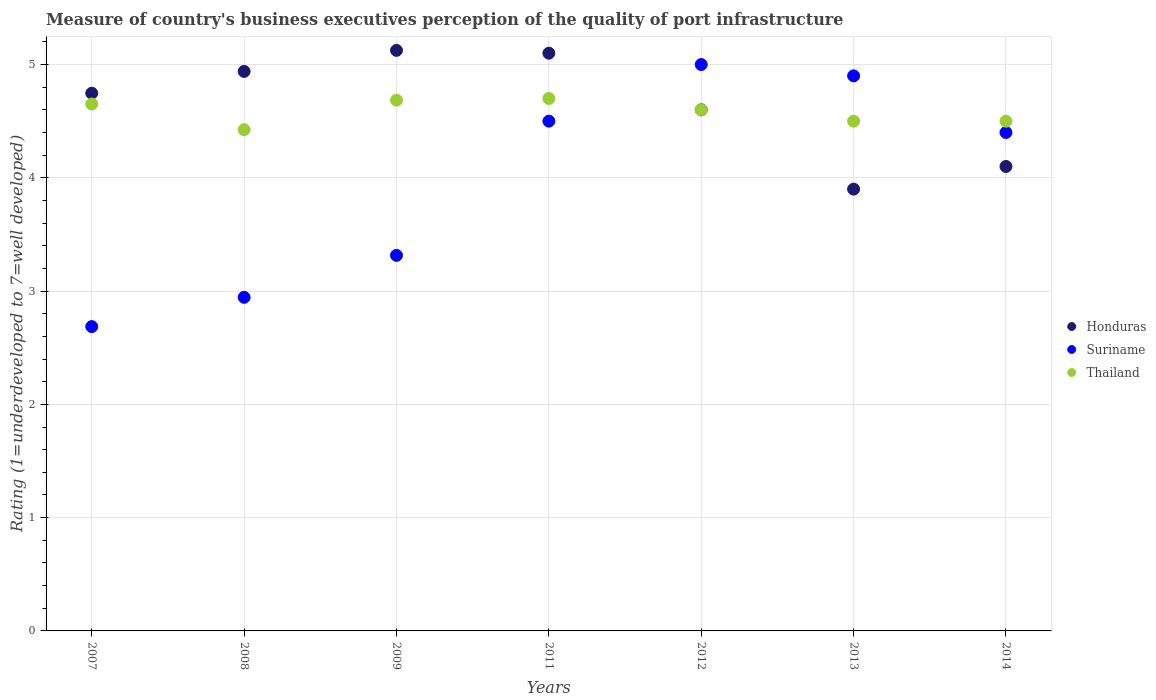Is the number of dotlines equal to the number of legend labels?
Make the answer very short. Yes. Across all years, what is the maximum ratings of the quality of port infrastructure in Suriname?
Provide a succinct answer. 5. Across all years, what is the minimum ratings of the quality of port infrastructure in Thailand?
Provide a succinct answer. 4.42. In which year was the ratings of the quality of port infrastructure in Thailand minimum?
Provide a short and direct response. 2008. What is the total ratings of the quality of port infrastructure in Thailand in the graph?
Provide a short and direct response. 32.06. What is the difference between the ratings of the quality of port infrastructure in Suriname in 2011 and that in 2014?
Make the answer very short. 0.1. What is the difference between the ratings of the quality of port infrastructure in Thailand in 2011 and the ratings of the quality of port infrastructure in Suriname in 2013?
Ensure brevity in your answer.  -0.2. What is the average ratings of the quality of port infrastructure in Honduras per year?
Your answer should be compact. 4.64. In the year 2011, what is the difference between the ratings of the quality of port infrastructure in Thailand and ratings of the quality of port infrastructure in Suriname?
Offer a terse response. 0.2. What is the ratio of the ratings of the quality of port infrastructure in Honduras in 2007 to that in 2014?
Offer a very short reply. 1.16. Is the ratings of the quality of port infrastructure in Honduras in 2007 less than that in 2011?
Offer a terse response. Yes. What is the difference between the highest and the second highest ratings of the quality of port infrastructure in Thailand?
Offer a terse response. 0.01. What is the difference between the highest and the lowest ratings of the quality of port infrastructure in Suriname?
Your answer should be compact. 2.31. In how many years, is the ratings of the quality of port infrastructure in Thailand greater than the average ratings of the quality of port infrastructure in Thailand taken over all years?
Your answer should be compact. 4. Is it the case that in every year, the sum of the ratings of the quality of port infrastructure in Thailand and ratings of the quality of port infrastructure in Suriname  is greater than the ratings of the quality of port infrastructure in Honduras?
Give a very brief answer. Yes. Is the ratings of the quality of port infrastructure in Suriname strictly less than the ratings of the quality of port infrastructure in Thailand over the years?
Provide a succinct answer. No. Are the values on the major ticks of Y-axis written in scientific E-notation?
Your response must be concise. No. Does the graph contain grids?
Provide a succinct answer. Yes. How are the legend labels stacked?
Make the answer very short. Vertical. What is the title of the graph?
Provide a succinct answer. Measure of country's business executives perception of the quality of port infrastructure. Does "American Samoa" appear as one of the legend labels in the graph?
Your answer should be very brief. No. What is the label or title of the Y-axis?
Provide a short and direct response. Rating (1=underdeveloped to 7=well developed). What is the Rating (1=underdeveloped to 7=well developed) in Honduras in 2007?
Ensure brevity in your answer.  4.75. What is the Rating (1=underdeveloped to 7=well developed) in Suriname in 2007?
Make the answer very short. 2.69. What is the Rating (1=underdeveloped to 7=well developed) of Thailand in 2007?
Your answer should be very brief. 4.65. What is the Rating (1=underdeveloped to 7=well developed) in Honduras in 2008?
Your answer should be very brief. 4.94. What is the Rating (1=underdeveloped to 7=well developed) of Suriname in 2008?
Provide a succinct answer. 2.94. What is the Rating (1=underdeveloped to 7=well developed) in Thailand in 2008?
Provide a succinct answer. 4.42. What is the Rating (1=underdeveloped to 7=well developed) in Honduras in 2009?
Your answer should be compact. 5.12. What is the Rating (1=underdeveloped to 7=well developed) of Suriname in 2009?
Your response must be concise. 3.32. What is the Rating (1=underdeveloped to 7=well developed) in Thailand in 2009?
Keep it short and to the point. 4.69. What is the Rating (1=underdeveloped to 7=well developed) in Honduras in 2011?
Offer a very short reply. 5.1. What is the Rating (1=underdeveloped to 7=well developed) in Suriname in 2011?
Your response must be concise. 4.5. What is the Rating (1=underdeveloped to 7=well developed) in Thailand in 2011?
Your answer should be compact. 4.7. What is the Rating (1=underdeveloped to 7=well developed) of Honduras in 2012?
Give a very brief answer. 4.6. What is the Rating (1=underdeveloped to 7=well developed) in Suriname in 2012?
Your answer should be very brief. 5. What is the Rating (1=underdeveloped to 7=well developed) in Thailand in 2012?
Your answer should be very brief. 4.6. What is the Rating (1=underdeveloped to 7=well developed) of Honduras in 2013?
Provide a short and direct response. 3.9. What is the Rating (1=underdeveloped to 7=well developed) of Suriname in 2013?
Give a very brief answer. 4.9. What is the Rating (1=underdeveloped to 7=well developed) in Thailand in 2013?
Provide a short and direct response. 4.5. What is the Rating (1=underdeveloped to 7=well developed) of Suriname in 2014?
Offer a terse response. 4.4. What is the Rating (1=underdeveloped to 7=well developed) of Thailand in 2014?
Give a very brief answer. 4.5. Across all years, what is the maximum Rating (1=underdeveloped to 7=well developed) of Honduras?
Make the answer very short. 5.12. Across all years, what is the maximum Rating (1=underdeveloped to 7=well developed) of Suriname?
Ensure brevity in your answer.  5. Across all years, what is the maximum Rating (1=underdeveloped to 7=well developed) of Thailand?
Provide a short and direct response. 4.7. Across all years, what is the minimum Rating (1=underdeveloped to 7=well developed) in Suriname?
Your response must be concise. 2.69. Across all years, what is the minimum Rating (1=underdeveloped to 7=well developed) in Thailand?
Make the answer very short. 4.42. What is the total Rating (1=underdeveloped to 7=well developed) in Honduras in the graph?
Keep it short and to the point. 32.51. What is the total Rating (1=underdeveloped to 7=well developed) in Suriname in the graph?
Give a very brief answer. 27.75. What is the total Rating (1=underdeveloped to 7=well developed) of Thailand in the graph?
Your answer should be compact. 32.06. What is the difference between the Rating (1=underdeveloped to 7=well developed) in Honduras in 2007 and that in 2008?
Ensure brevity in your answer.  -0.19. What is the difference between the Rating (1=underdeveloped to 7=well developed) of Suriname in 2007 and that in 2008?
Your answer should be compact. -0.26. What is the difference between the Rating (1=underdeveloped to 7=well developed) of Thailand in 2007 and that in 2008?
Ensure brevity in your answer.  0.23. What is the difference between the Rating (1=underdeveloped to 7=well developed) in Honduras in 2007 and that in 2009?
Provide a succinct answer. -0.38. What is the difference between the Rating (1=underdeveloped to 7=well developed) in Suriname in 2007 and that in 2009?
Offer a terse response. -0.63. What is the difference between the Rating (1=underdeveloped to 7=well developed) of Thailand in 2007 and that in 2009?
Offer a terse response. -0.03. What is the difference between the Rating (1=underdeveloped to 7=well developed) of Honduras in 2007 and that in 2011?
Provide a short and direct response. -0.35. What is the difference between the Rating (1=underdeveloped to 7=well developed) in Suriname in 2007 and that in 2011?
Offer a very short reply. -1.81. What is the difference between the Rating (1=underdeveloped to 7=well developed) of Thailand in 2007 and that in 2011?
Your answer should be very brief. -0.05. What is the difference between the Rating (1=underdeveloped to 7=well developed) in Honduras in 2007 and that in 2012?
Give a very brief answer. 0.15. What is the difference between the Rating (1=underdeveloped to 7=well developed) in Suriname in 2007 and that in 2012?
Your response must be concise. -2.31. What is the difference between the Rating (1=underdeveloped to 7=well developed) of Thailand in 2007 and that in 2012?
Ensure brevity in your answer.  0.05. What is the difference between the Rating (1=underdeveloped to 7=well developed) in Honduras in 2007 and that in 2013?
Ensure brevity in your answer.  0.85. What is the difference between the Rating (1=underdeveloped to 7=well developed) in Suriname in 2007 and that in 2013?
Keep it short and to the point. -2.21. What is the difference between the Rating (1=underdeveloped to 7=well developed) in Thailand in 2007 and that in 2013?
Your response must be concise. 0.15. What is the difference between the Rating (1=underdeveloped to 7=well developed) in Honduras in 2007 and that in 2014?
Make the answer very short. 0.65. What is the difference between the Rating (1=underdeveloped to 7=well developed) in Suriname in 2007 and that in 2014?
Offer a very short reply. -1.71. What is the difference between the Rating (1=underdeveloped to 7=well developed) of Thailand in 2007 and that in 2014?
Provide a short and direct response. 0.15. What is the difference between the Rating (1=underdeveloped to 7=well developed) in Honduras in 2008 and that in 2009?
Your answer should be very brief. -0.19. What is the difference between the Rating (1=underdeveloped to 7=well developed) in Suriname in 2008 and that in 2009?
Ensure brevity in your answer.  -0.37. What is the difference between the Rating (1=underdeveloped to 7=well developed) in Thailand in 2008 and that in 2009?
Ensure brevity in your answer.  -0.26. What is the difference between the Rating (1=underdeveloped to 7=well developed) in Honduras in 2008 and that in 2011?
Your answer should be compact. -0.16. What is the difference between the Rating (1=underdeveloped to 7=well developed) of Suriname in 2008 and that in 2011?
Provide a succinct answer. -1.55. What is the difference between the Rating (1=underdeveloped to 7=well developed) of Thailand in 2008 and that in 2011?
Provide a short and direct response. -0.28. What is the difference between the Rating (1=underdeveloped to 7=well developed) in Honduras in 2008 and that in 2012?
Your response must be concise. 0.34. What is the difference between the Rating (1=underdeveloped to 7=well developed) in Suriname in 2008 and that in 2012?
Make the answer very short. -2.06. What is the difference between the Rating (1=underdeveloped to 7=well developed) in Thailand in 2008 and that in 2012?
Ensure brevity in your answer.  -0.18. What is the difference between the Rating (1=underdeveloped to 7=well developed) in Honduras in 2008 and that in 2013?
Ensure brevity in your answer.  1.04. What is the difference between the Rating (1=underdeveloped to 7=well developed) of Suriname in 2008 and that in 2013?
Provide a short and direct response. -1.96. What is the difference between the Rating (1=underdeveloped to 7=well developed) in Thailand in 2008 and that in 2013?
Provide a short and direct response. -0.08. What is the difference between the Rating (1=underdeveloped to 7=well developed) in Honduras in 2008 and that in 2014?
Your answer should be compact. 0.84. What is the difference between the Rating (1=underdeveloped to 7=well developed) in Suriname in 2008 and that in 2014?
Make the answer very short. -1.46. What is the difference between the Rating (1=underdeveloped to 7=well developed) of Thailand in 2008 and that in 2014?
Provide a short and direct response. -0.08. What is the difference between the Rating (1=underdeveloped to 7=well developed) in Honduras in 2009 and that in 2011?
Provide a succinct answer. 0.02. What is the difference between the Rating (1=underdeveloped to 7=well developed) in Suriname in 2009 and that in 2011?
Provide a succinct answer. -1.18. What is the difference between the Rating (1=underdeveloped to 7=well developed) in Thailand in 2009 and that in 2011?
Make the answer very short. -0.01. What is the difference between the Rating (1=underdeveloped to 7=well developed) of Honduras in 2009 and that in 2012?
Your answer should be very brief. 0.52. What is the difference between the Rating (1=underdeveloped to 7=well developed) in Suriname in 2009 and that in 2012?
Offer a very short reply. -1.68. What is the difference between the Rating (1=underdeveloped to 7=well developed) of Thailand in 2009 and that in 2012?
Keep it short and to the point. 0.09. What is the difference between the Rating (1=underdeveloped to 7=well developed) in Honduras in 2009 and that in 2013?
Your response must be concise. 1.22. What is the difference between the Rating (1=underdeveloped to 7=well developed) of Suriname in 2009 and that in 2013?
Provide a succinct answer. -1.58. What is the difference between the Rating (1=underdeveloped to 7=well developed) in Thailand in 2009 and that in 2013?
Provide a short and direct response. 0.19. What is the difference between the Rating (1=underdeveloped to 7=well developed) in Honduras in 2009 and that in 2014?
Give a very brief answer. 1.02. What is the difference between the Rating (1=underdeveloped to 7=well developed) of Suriname in 2009 and that in 2014?
Provide a short and direct response. -1.08. What is the difference between the Rating (1=underdeveloped to 7=well developed) in Thailand in 2009 and that in 2014?
Your answer should be very brief. 0.19. What is the difference between the Rating (1=underdeveloped to 7=well developed) in Honduras in 2011 and that in 2012?
Provide a short and direct response. 0.5. What is the difference between the Rating (1=underdeveloped to 7=well developed) in Suriname in 2011 and that in 2012?
Ensure brevity in your answer.  -0.5. What is the difference between the Rating (1=underdeveloped to 7=well developed) in Thailand in 2011 and that in 2012?
Give a very brief answer. 0.1. What is the difference between the Rating (1=underdeveloped to 7=well developed) of Suriname in 2011 and that in 2013?
Ensure brevity in your answer.  -0.4. What is the difference between the Rating (1=underdeveloped to 7=well developed) of Thailand in 2011 and that in 2013?
Your answer should be very brief. 0.2. What is the difference between the Rating (1=underdeveloped to 7=well developed) in Honduras in 2012 and that in 2013?
Keep it short and to the point. 0.7. What is the difference between the Rating (1=underdeveloped to 7=well developed) of Thailand in 2012 and that in 2013?
Offer a very short reply. 0.1. What is the difference between the Rating (1=underdeveloped to 7=well developed) of Honduras in 2012 and that in 2014?
Give a very brief answer. 0.5. What is the difference between the Rating (1=underdeveloped to 7=well developed) in Suriname in 2012 and that in 2014?
Make the answer very short. 0.6. What is the difference between the Rating (1=underdeveloped to 7=well developed) in Honduras in 2013 and that in 2014?
Your response must be concise. -0.2. What is the difference between the Rating (1=underdeveloped to 7=well developed) in Honduras in 2007 and the Rating (1=underdeveloped to 7=well developed) in Suriname in 2008?
Your response must be concise. 1.8. What is the difference between the Rating (1=underdeveloped to 7=well developed) of Honduras in 2007 and the Rating (1=underdeveloped to 7=well developed) of Thailand in 2008?
Ensure brevity in your answer.  0.32. What is the difference between the Rating (1=underdeveloped to 7=well developed) in Suriname in 2007 and the Rating (1=underdeveloped to 7=well developed) in Thailand in 2008?
Ensure brevity in your answer.  -1.74. What is the difference between the Rating (1=underdeveloped to 7=well developed) of Honduras in 2007 and the Rating (1=underdeveloped to 7=well developed) of Suriname in 2009?
Provide a succinct answer. 1.43. What is the difference between the Rating (1=underdeveloped to 7=well developed) of Honduras in 2007 and the Rating (1=underdeveloped to 7=well developed) of Thailand in 2009?
Your response must be concise. 0.06. What is the difference between the Rating (1=underdeveloped to 7=well developed) in Suriname in 2007 and the Rating (1=underdeveloped to 7=well developed) in Thailand in 2009?
Your answer should be very brief. -2. What is the difference between the Rating (1=underdeveloped to 7=well developed) in Honduras in 2007 and the Rating (1=underdeveloped to 7=well developed) in Suriname in 2011?
Give a very brief answer. 0.25. What is the difference between the Rating (1=underdeveloped to 7=well developed) in Honduras in 2007 and the Rating (1=underdeveloped to 7=well developed) in Thailand in 2011?
Ensure brevity in your answer.  0.05. What is the difference between the Rating (1=underdeveloped to 7=well developed) of Suriname in 2007 and the Rating (1=underdeveloped to 7=well developed) of Thailand in 2011?
Provide a succinct answer. -2.01. What is the difference between the Rating (1=underdeveloped to 7=well developed) in Honduras in 2007 and the Rating (1=underdeveloped to 7=well developed) in Suriname in 2012?
Ensure brevity in your answer.  -0.25. What is the difference between the Rating (1=underdeveloped to 7=well developed) of Honduras in 2007 and the Rating (1=underdeveloped to 7=well developed) of Thailand in 2012?
Provide a short and direct response. 0.15. What is the difference between the Rating (1=underdeveloped to 7=well developed) of Suriname in 2007 and the Rating (1=underdeveloped to 7=well developed) of Thailand in 2012?
Your answer should be very brief. -1.91. What is the difference between the Rating (1=underdeveloped to 7=well developed) in Honduras in 2007 and the Rating (1=underdeveloped to 7=well developed) in Suriname in 2013?
Your response must be concise. -0.15. What is the difference between the Rating (1=underdeveloped to 7=well developed) of Honduras in 2007 and the Rating (1=underdeveloped to 7=well developed) of Thailand in 2013?
Give a very brief answer. 0.25. What is the difference between the Rating (1=underdeveloped to 7=well developed) of Suriname in 2007 and the Rating (1=underdeveloped to 7=well developed) of Thailand in 2013?
Your answer should be very brief. -1.81. What is the difference between the Rating (1=underdeveloped to 7=well developed) in Honduras in 2007 and the Rating (1=underdeveloped to 7=well developed) in Suriname in 2014?
Your answer should be compact. 0.35. What is the difference between the Rating (1=underdeveloped to 7=well developed) in Honduras in 2007 and the Rating (1=underdeveloped to 7=well developed) in Thailand in 2014?
Make the answer very short. 0.25. What is the difference between the Rating (1=underdeveloped to 7=well developed) of Suriname in 2007 and the Rating (1=underdeveloped to 7=well developed) of Thailand in 2014?
Provide a short and direct response. -1.81. What is the difference between the Rating (1=underdeveloped to 7=well developed) in Honduras in 2008 and the Rating (1=underdeveloped to 7=well developed) in Suriname in 2009?
Your answer should be very brief. 1.62. What is the difference between the Rating (1=underdeveloped to 7=well developed) of Honduras in 2008 and the Rating (1=underdeveloped to 7=well developed) of Thailand in 2009?
Provide a short and direct response. 0.25. What is the difference between the Rating (1=underdeveloped to 7=well developed) in Suriname in 2008 and the Rating (1=underdeveloped to 7=well developed) in Thailand in 2009?
Give a very brief answer. -1.74. What is the difference between the Rating (1=underdeveloped to 7=well developed) in Honduras in 2008 and the Rating (1=underdeveloped to 7=well developed) in Suriname in 2011?
Give a very brief answer. 0.44. What is the difference between the Rating (1=underdeveloped to 7=well developed) of Honduras in 2008 and the Rating (1=underdeveloped to 7=well developed) of Thailand in 2011?
Your response must be concise. 0.24. What is the difference between the Rating (1=underdeveloped to 7=well developed) of Suriname in 2008 and the Rating (1=underdeveloped to 7=well developed) of Thailand in 2011?
Provide a short and direct response. -1.75. What is the difference between the Rating (1=underdeveloped to 7=well developed) of Honduras in 2008 and the Rating (1=underdeveloped to 7=well developed) of Suriname in 2012?
Offer a very short reply. -0.06. What is the difference between the Rating (1=underdeveloped to 7=well developed) of Honduras in 2008 and the Rating (1=underdeveloped to 7=well developed) of Thailand in 2012?
Offer a terse response. 0.34. What is the difference between the Rating (1=underdeveloped to 7=well developed) in Suriname in 2008 and the Rating (1=underdeveloped to 7=well developed) in Thailand in 2012?
Ensure brevity in your answer.  -1.66. What is the difference between the Rating (1=underdeveloped to 7=well developed) in Honduras in 2008 and the Rating (1=underdeveloped to 7=well developed) in Suriname in 2013?
Keep it short and to the point. 0.04. What is the difference between the Rating (1=underdeveloped to 7=well developed) of Honduras in 2008 and the Rating (1=underdeveloped to 7=well developed) of Thailand in 2013?
Offer a terse response. 0.44. What is the difference between the Rating (1=underdeveloped to 7=well developed) in Suriname in 2008 and the Rating (1=underdeveloped to 7=well developed) in Thailand in 2013?
Make the answer very short. -1.55. What is the difference between the Rating (1=underdeveloped to 7=well developed) in Honduras in 2008 and the Rating (1=underdeveloped to 7=well developed) in Suriname in 2014?
Make the answer very short. 0.54. What is the difference between the Rating (1=underdeveloped to 7=well developed) of Honduras in 2008 and the Rating (1=underdeveloped to 7=well developed) of Thailand in 2014?
Keep it short and to the point. 0.44. What is the difference between the Rating (1=underdeveloped to 7=well developed) in Suriname in 2008 and the Rating (1=underdeveloped to 7=well developed) in Thailand in 2014?
Your answer should be compact. -1.55. What is the difference between the Rating (1=underdeveloped to 7=well developed) in Honduras in 2009 and the Rating (1=underdeveloped to 7=well developed) in Suriname in 2011?
Keep it short and to the point. 0.62. What is the difference between the Rating (1=underdeveloped to 7=well developed) of Honduras in 2009 and the Rating (1=underdeveloped to 7=well developed) of Thailand in 2011?
Your response must be concise. 0.42. What is the difference between the Rating (1=underdeveloped to 7=well developed) in Suriname in 2009 and the Rating (1=underdeveloped to 7=well developed) in Thailand in 2011?
Your answer should be very brief. -1.38. What is the difference between the Rating (1=underdeveloped to 7=well developed) in Honduras in 2009 and the Rating (1=underdeveloped to 7=well developed) in Suriname in 2012?
Give a very brief answer. 0.12. What is the difference between the Rating (1=underdeveloped to 7=well developed) of Honduras in 2009 and the Rating (1=underdeveloped to 7=well developed) of Thailand in 2012?
Make the answer very short. 0.52. What is the difference between the Rating (1=underdeveloped to 7=well developed) in Suriname in 2009 and the Rating (1=underdeveloped to 7=well developed) in Thailand in 2012?
Your answer should be compact. -1.28. What is the difference between the Rating (1=underdeveloped to 7=well developed) in Honduras in 2009 and the Rating (1=underdeveloped to 7=well developed) in Suriname in 2013?
Your answer should be compact. 0.22. What is the difference between the Rating (1=underdeveloped to 7=well developed) of Honduras in 2009 and the Rating (1=underdeveloped to 7=well developed) of Thailand in 2013?
Keep it short and to the point. 0.62. What is the difference between the Rating (1=underdeveloped to 7=well developed) in Suriname in 2009 and the Rating (1=underdeveloped to 7=well developed) in Thailand in 2013?
Your answer should be compact. -1.18. What is the difference between the Rating (1=underdeveloped to 7=well developed) in Honduras in 2009 and the Rating (1=underdeveloped to 7=well developed) in Suriname in 2014?
Provide a short and direct response. 0.72. What is the difference between the Rating (1=underdeveloped to 7=well developed) in Honduras in 2009 and the Rating (1=underdeveloped to 7=well developed) in Thailand in 2014?
Provide a short and direct response. 0.62. What is the difference between the Rating (1=underdeveloped to 7=well developed) in Suriname in 2009 and the Rating (1=underdeveloped to 7=well developed) in Thailand in 2014?
Your answer should be very brief. -1.18. What is the difference between the Rating (1=underdeveloped to 7=well developed) in Honduras in 2011 and the Rating (1=underdeveloped to 7=well developed) in Thailand in 2012?
Give a very brief answer. 0.5. What is the difference between the Rating (1=underdeveloped to 7=well developed) of Suriname in 2011 and the Rating (1=underdeveloped to 7=well developed) of Thailand in 2012?
Your answer should be compact. -0.1. What is the difference between the Rating (1=underdeveloped to 7=well developed) in Honduras in 2011 and the Rating (1=underdeveloped to 7=well developed) in Suriname in 2013?
Your response must be concise. 0.2. What is the difference between the Rating (1=underdeveloped to 7=well developed) of Honduras in 2011 and the Rating (1=underdeveloped to 7=well developed) of Thailand in 2013?
Your answer should be compact. 0.6. What is the difference between the Rating (1=underdeveloped to 7=well developed) of Honduras in 2011 and the Rating (1=underdeveloped to 7=well developed) of Suriname in 2014?
Make the answer very short. 0.7. What is the difference between the Rating (1=underdeveloped to 7=well developed) of Honduras in 2011 and the Rating (1=underdeveloped to 7=well developed) of Thailand in 2014?
Give a very brief answer. 0.6. What is the difference between the Rating (1=underdeveloped to 7=well developed) in Honduras in 2012 and the Rating (1=underdeveloped to 7=well developed) in Suriname in 2013?
Offer a very short reply. -0.3. What is the difference between the Rating (1=underdeveloped to 7=well developed) in Honduras in 2012 and the Rating (1=underdeveloped to 7=well developed) in Suriname in 2014?
Your answer should be very brief. 0.2. What is the difference between the Rating (1=underdeveloped to 7=well developed) of Suriname in 2012 and the Rating (1=underdeveloped to 7=well developed) of Thailand in 2014?
Keep it short and to the point. 0.5. What is the difference between the Rating (1=underdeveloped to 7=well developed) in Honduras in 2013 and the Rating (1=underdeveloped to 7=well developed) in Thailand in 2014?
Provide a succinct answer. -0.6. What is the average Rating (1=underdeveloped to 7=well developed) of Honduras per year?
Ensure brevity in your answer.  4.64. What is the average Rating (1=underdeveloped to 7=well developed) of Suriname per year?
Make the answer very short. 3.96. What is the average Rating (1=underdeveloped to 7=well developed) in Thailand per year?
Your response must be concise. 4.58. In the year 2007, what is the difference between the Rating (1=underdeveloped to 7=well developed) of Honduras and Rating (1=underdeveloped to 7=well developed) of Suriname?
Ensure brevity in your answer.  2.06. In the year 2007, what is the difference between the Rating (1=underdeveloped to 7=well developed) of Honduras and Rating (1=underdeveloped to 7=well developed) of Thailand?
Your response must be concise. 0.1. In the year 2007, what is the difference between the Rating (1=underdeveloped to 7=well developed) of Suriname and Rating (1=underdeveloped to 7=well developed) of Thailand?
Offer a terse response. -1.97. In the year 2008, what is the difference between the Rating (1=underdeveloped to 7=well developed) in Honduras and Rating (1=underdeveloped to 7=well developed) in Suriname?
Your response must be concise. 1.99. In the year 2008, what is the difference between the Rating (1=underdeveloped to 7=well developed) of Honduras and Rating (1=underdeveloped to 7=well developed) of Thailand?
Offer a very short reply. 0.51. In the year 2008, what is the difference between the Rating (1=underdeveloped to 7=well developed) in Suriname and Rating (1=underdeveloped to 7=well developed) in Thailand?
Your answer should be compact. -1.48. In the year 2009, what is the difference between the Rating (1=underdeveloped to 7=well developed) in Honduras and Rating (1=underdeveloped to 7=well developed) in Suriname?
Your answer should be compact. 1.81. In the year 2009, what is the difference between the Rating (1=underdeveloped to 7=well developed) in Honduras and Rating (1=underdeveloped to 7=well developed) in Thailand?
Offer a very short reply. 0.44. In the year 2009, what is the difference between the Rating (1=underdeveloped to 7=well developed) in Suriname and Rating (1=underdeveloped to 7=well developed) in Thailand?
Make the answer very short. -1.37. In the year 2011, what is the difference between the Rating (1=underdeveloped to 7=well developed) of Honduras and Rating (1=underdeveloped to 7=well developed) of Thailand?
Provide a succinct answer. 0.4. In the year 2012, what is the difference between the Rating (1=underdeveloped to 7=well developed) of Honduras and Rating (1=underdeveloped to 7=well developed) of Thailand?
Keep it short and to the point. 0. In the year 2012, what is the difference between the Rating (1=underdeveloped to 7=well developed) in Suriname and Rating (1=underdeveloped to 7=well developed) in Thailand?
Ensure brevity in your answer.  0.4. In the year 2014, what is the difference between the Rating (1=underdeveloped to 7=well developed) in Honduras and Rating (1=underdeveloped to 7=well developed) in Suriname?
Provide a succinct answer. -0.3. In the year 2014, what is the difference between the Rating (1=underdeveloped to 7=well developed) in Honduras and Rating (1=underdeveloped to 7=well developed) in Thailand?
Your answer should be compact. -0.4. In the year 2014, what is the difference between the Rating (1=underdeveloped to 7=well developed) of Suriname and Rating (1=underdeveloped to 7=well developed) of Thailand?
Offer a terse response. -0.1. What is the ratio of the Rating (1=underdeveloped to 7=well developed) of Suriname in 2007 to that in 2008?
Provide a short and direct response. 0.91. What is the ratio of the Rating (1=underdeveloped to 7=well developed) of Thailand in 2007 to that in 2008?
Provide a short and direct response. 1.05. What is the ratio of the Rating (1=underdeveloped to 7=well developed) of Honduras in 2007 to that in 2009?
Offer a terse response. 0.93. What is the ratio of the Rating (1=underdeveloped to 7=well developed) of Suriname in 2007 to that in 2009?
Offer a very short reply. 0.81. What is the ratio of the Rating (1=underdeveloped to 7=well developed) in Thailand in 2007 to that in 2009?
Give a very brief answer. 0.99. What is the ratio of the Rating (1=underdeveloped to 7=well developed) in Honduras in 2007 to that in 2011?
Provide a succinct answer. 0.93. What is the ratio of the Rating (1=underdeveloped to 7=well developed) of Suriname in 2007 to that in 2011?
Ensure brevity in your answer.  0.6. What is the ratio of the Rating (1=underdeveloped to 7=well developed) in Honduras in 2007 to that in 2012?
Ensure brevity in your answer.  1.03. What is the ratio of the Rating (1=underdeveloped to 7=well developed) of Suriname in 2007 to that in 2012?
Make the answer very short. 0.54. What is the ratio of the Rating (1=underdeveloped to 7=well developed) in Thailand in 2007 to that in 2012?
Your answer should be very brief. 1.01. What is the ratio of the Rating (1=underdeveloped to 7=well developed) of Honduras in 2007 to that in 2013?
Make the answer very short. 1.22. What is the ratio of the Rating (1=underdeveloped to 7=well developed) of Suriname in 2007 to that in 2013?
Provide a succinct answer. 0.55. What is the ratio of the Rating (1=underdeveloped to 7=well developed) in Thailand in 2007 to that in 2013?
Provide a short and direct response. 1.03. What is the ratio of the Rating (1=underdeveloped to 7=well developed) of Honduras in 2007 to that in 2014?
Ensure brevity in your answer.  1.16. What is the ratio of the Rating (1=underdeveloped to 7=well developed) in Suriname in 2007 to that in 2014?
Provide a succinct answer. 0.61. What is the ratio of the Rating (1=underdeveloped to 7=well developed) in Thailand in 2007 to that in 2014?
Your answer should be compact. 1.03. What is the ratio of the Rating (1=underdeveloped to 7=well developed) in Honduras in 2008 to that in 2009?
Your answer should be compact. 0.96. What is the ratio of the Rating (1=underdeveloped to 7=well developed) of Suriname in 2008 to that in 2009?
Ensure brevity in your answer.  0.89. What is the ratio of the Rating (1=underdeveloped to 7=well developed) in Thailand in 2008 to that in 2009?
Make the answer very short. 0.94. What is the ratio of the Rating (1=underdeveloped to 7=well developed) of Honduras in 2008 to that in 2011?
Your answer should be compact. 0.97. What is the ratio of the Rating (1=underdeveloped to 7=well developed) of Suriname in 2008 to that in 2011?
Offer a terse response. 0.65. What is the ratio of the Rating (1=underdeveloped to 7=well developed) of Thailand in 2008 to that in 2011?
Your answer should be very brief. 0.94. What is the ratio of the Rating (1=underdeveloped to 7=well developed) in Honduras in 2008 to that in 2012?
Give a very brief answer. 1.07. What is the ratio of the Rating (1=underdeveloped to 7=well developed) of Suriname in 2008 to that in 2012?
Make the answer very short. 0.59. What is the ratio of the Rating (1=underdeveloped to 7=well developed) of Thailand in 2008 to that in 2012?
Offer a terse response. 0.96. What is the ratio of the Rating (1=underdeveloped to 7=well developed) in Honduras in 2008 to that in 2013?
Your answer should be very brief. 1.27. What is the ratio of the Rating (1=underdeveloped to 7=well developed) in Suriname in 2008 to that in 2013?
Keep it short and to the point. 0.6. What is the ratio of the Rating (1=underdeveloped to 7=well developed) in Thailand in 2008 to that in 2013?
Ensure brevity in your answer.  0.98. What is the ratio of the Rating (1=underdeveloped to 7=well developed) in Honduras in 2008 to that in 2014?
Ensure brevity in your answer.  1.2. What is the ratio of the Rating (1=underdeveloped to 7=well developed) of Suriname in 2008 to that in 2014?
Your answer should be compact. 0.67. What is the ratio of the Rating (1=underdeveloped to 7=well developed) of Thailand in 2008 to that in 2014?
Your answer should be very brief. 0.98. What is the ratio of the Rating (1=underdeveloped to 7=well developed) of Suriname in 2009 to that in 2011?
Make the answer very short. 0.74. What is the ratio of the Rating (1=underdeveloped to 7=well developed) in Thailand in 2009 to that in 2011?
Your response must be concise. 1. What is the ratio of the Rating (1=underdeveloped to 7=well developed) in Honduras in 2009 to that in 2012?
Offer a terse response. 1.11. What is the ratio of the Rating (1=underdeveloped to 7=well developed) of Suriname in 2009 to that in 2012?
Offer a very short reply. 0.66. What is the ratio of the Rating (1=underdeveloped to 7=well developed) in Thailand in 2009 to that in 2012?
Offer a very short reply. 1.02. What is the ratio of the Rating (1=underdeveloped to 7=well developed) of Honduras in 2009 to that in 2013?
Your answer should be very brief. 1.31. What is the ratio of the Rating (1=underdeveloped to 7=well developed) of Suriname in 2009 to that in 2013?
Provide a succinct answer. 0.68. What is the ratio of the Rating (1=underdeveloped to 7=well developed) of Thailand in 2009 to that in 2013?
Give a very brief answer. 1.04. What is the ratio of the Rating (1=underdeveloped to 7=well developed) of Suriname in 2009 to that in 2014?
Provide a short and direct response. 0.75. What is the ratio of the Rating (1=underdeveloped to 7=well developed) of Thailand in 2009 to that in 2014?
Give a very brief answer. 1.04. What is the ratio of the Rating (1=underdeveloped to 7=well developed) in Honduras in 2011 to that in 2012?
Your answer should be very brief. 1.11. What is the ratio of the Rating (1=underdeveloped to 7=well developed) of Suriname in 2011 to that in 2012?
Offer a terse response. 0.9. What is the ratio of the Rating (1=underdeveloped to 7=well developed) in Thailand in 2011 to that in 2012?
Ensure brevity in your answer.  1.02. What is the ratio of the Rating (1=underdeveloped to 7=well developed) of Honduras in 2011 to that in 2013?
Ensure brevity in your answer.  1.31. What is the ratio of the Rating (1=underdeveloped to 7=well developed) in Suriname in 2011 to that in 2013?
Give a very brief answer. 0.92. What is the ratio of the Rating (1=underdeveloped to 7=well developed) of Thailand in 2011 to that in 2013?
Keep it short and to the point. 1.04. What is the ratio of the Rating (1=underdeveloped to 7=well developed) of Honduras in 2011 to that in 2014?
Your response must be concise. 1.24. What is the ratio of the Rating (1=underdeveloped to 7=well developed) in Suriname in 2011 to that in 2014?
Your response must be concise. 1.02. What is the ratio of the Rating (1=underdeveloped to 7=well developed) of Thailand in 2011 to that in 2014?
Your answer should be very brief. 1.04. What is the ratio of the Rating (1=underdeveloped to 7=well developed) of Honduras in 2012 to that in 2013?
Give a very brief answer. 1.18. What is the ratio of the Rating (1=underdeveloped to 7=well developed) in Suriname in 2012 to that in 2013?
Offer a very short reply. 1.02. What is the ratio of the Rating (1=underdeveloped to 7=well developed) in Thailand in 2012 to that in 2013?
Offer a terse response. 1.02. What is the ratio of the Rating (1=underdeveloped to 7=well developed) of Honduras in 2012 to that in 2014?
Your answer should be very brief. 1.12. What is the ratio of the Rating (1=underdeveloped to 7=well developed) of Suriname in 2012 to that in 2014?
Your answer should be very brief. 1.14. What is the ratio of the Rating (1=underdeveloped to 7=well developed) of Thailand in 2012 to that in 2014?
Provide a succinct answer. 1.02. What is the ratio of the Rating (1=underdeveloped to 7=well developed) of Honduras in 2013 to that in 2014?
Offer a very short reply. 0.95. What is the ratio of the Rating (1=underdeveloped to 7=well developed) of Suriname in 2013 to that in 2014?
Your answer should be compact. 1.11. What is the ratio of the Rating (1=underdeveloped to 7=well developed) in Thailand in 2013 to that in 2014?
Ensure brevity in your answer.  1. What is the difference between the highest and the second highest Rating (1=underdeveloped to 7=well developed) in Honduras?
Provide a succinct answer. 0.02. What is the difference between the highest and the second highest Rating (1=underdeveloped to 7=well developed) of Thailand?
Offer a terse response. 0.01. What is the difference between the highest and the lowest Rating (1=underdeveloped to 7=well developed) of Honduras?
Give a very brief answer. 1.22. What is the difference between the highest and the lowest Rating (1=underdeveloped to 7=well developed) of Suriname?
Provide a succinct answer. 2.31. What is the difference between the highest and the lowest Rating (1=underdeveloped to 7=well developed) in Thailand?
Keep it short and to the point. 0.28. 